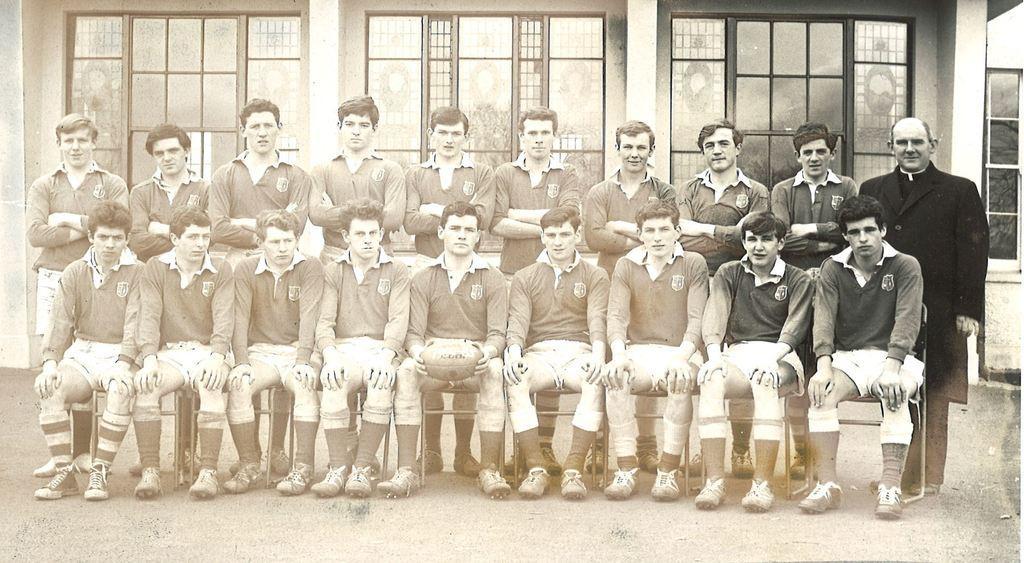Can you describe this image briefly? In this image there are some persons sitting in middle of this image and there are some persons standing behind them. there are three windows in the background and there is a person at right side is wearing black color dress and the middle person of this image is holding a ball , and there are some chairs at bottom of this image. 